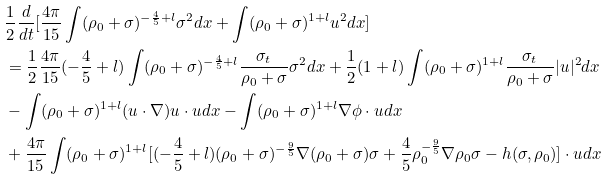Convert formula to latex. <formula><loc_0><loc_0><loc_500><loc_500>& \frac { 1 } { 2 } \frac { d } { d t } [ \frac { 4 \pi } { 1 5 } \int ( \rho _ { 0 } + \sigma ) ^ { - \frac { 4 } { 5 } + l } \sigma ^ { 2 } d x + \int ( \rho _ { 0 } + \sigma ) ^ { 1 + l } u ^ { 2 } d x ] \\ & = \frac { 1 } { 2 } \frac { 4 \pi } { 1 5 } ( - \frac { 4 } { 5 } + l ) \int ( \rho _ { 0 } + \sigma ) ^ { - \frac { 4 } { 5 } + l } \frac { \sigma _ { t } } { \rho _ { 0 } + \sigma } \sigma ^ { 2 } d x + \frac { 1 } { 2 } ( 1 + l ) \int ( \rho _ { 0 } + \sigma ) ^ { 1 + l } \frac { \sigma _ { t } } { \rho _ { 0 } + \sigma } | u | ^ { 2 } d x \\ & - \int ( \rho _ { 0 } + \sigma ) ^ { 1 + l } ( u \cdot \nabla ) u \cdot u d x - \int ( \rho _ { 0 } + \sigma ) ^ { 1 + l } \nabla \phi \cdot u d x \\ & + \frac { 4 \pi } { 1 5 } \int ( \rho _ { 0 } + \sigma ) ^ { 1 + l } [ ( - \frac { 4 } { 5 } + l ) ( \rho _ { 0 } + \sigma ) ^ { - \frac { 9 } { 5 } } \nabla ( \rho _ { 0 } + \sigma ) \sigma + \frac { 4 } { 5 } \rho _ { 0 } ^ { - \frac { 9 } { 5 } } \nabla \rho _ { 0 } \sigma - h ( \sigma , \rho _ { 0 } ) ] \cdot u d x \\</formula> 